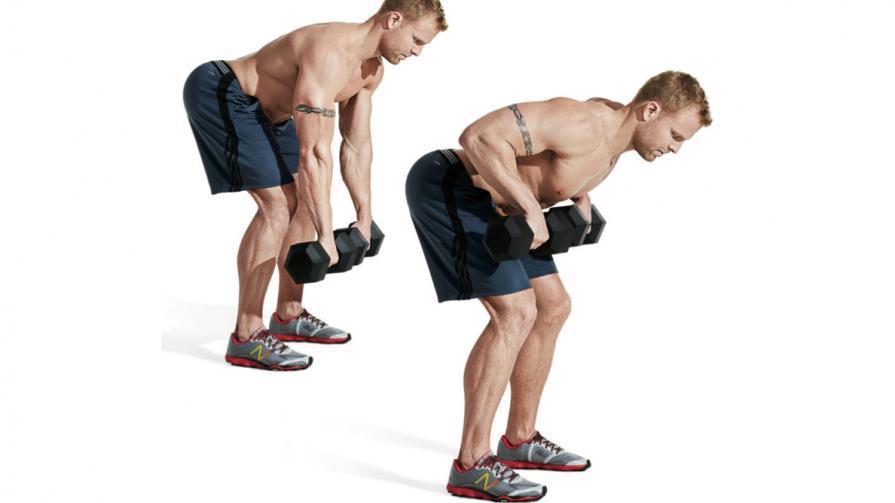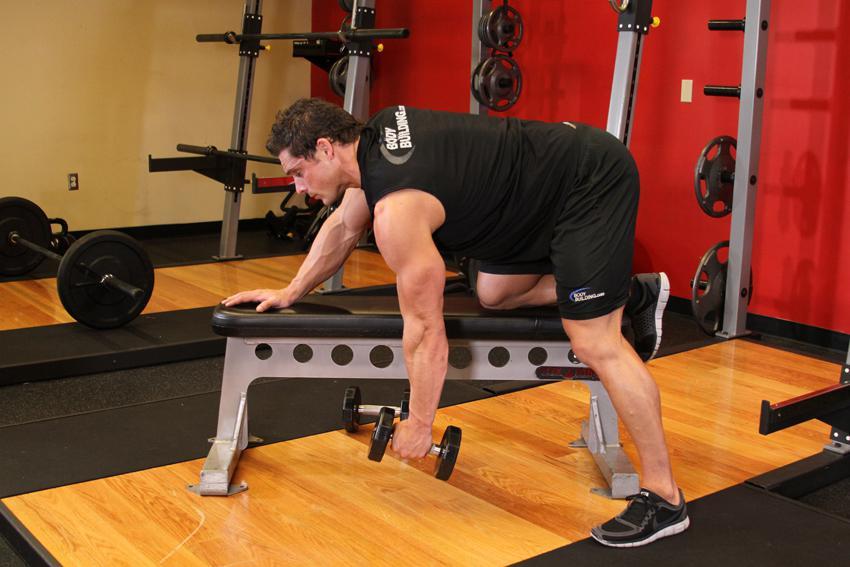The first image is the image on the left, the second image is the image on the right. Considering the images on both sides, is "An image shows a woman bending forward while holding dumbell weights." valid? Answer yes or no. No. The first image is the image on the left, the second image is the image on the right. For the images shown, is this caption "There is no less than one woman lifting weights" true? Answer yes or no. No. 